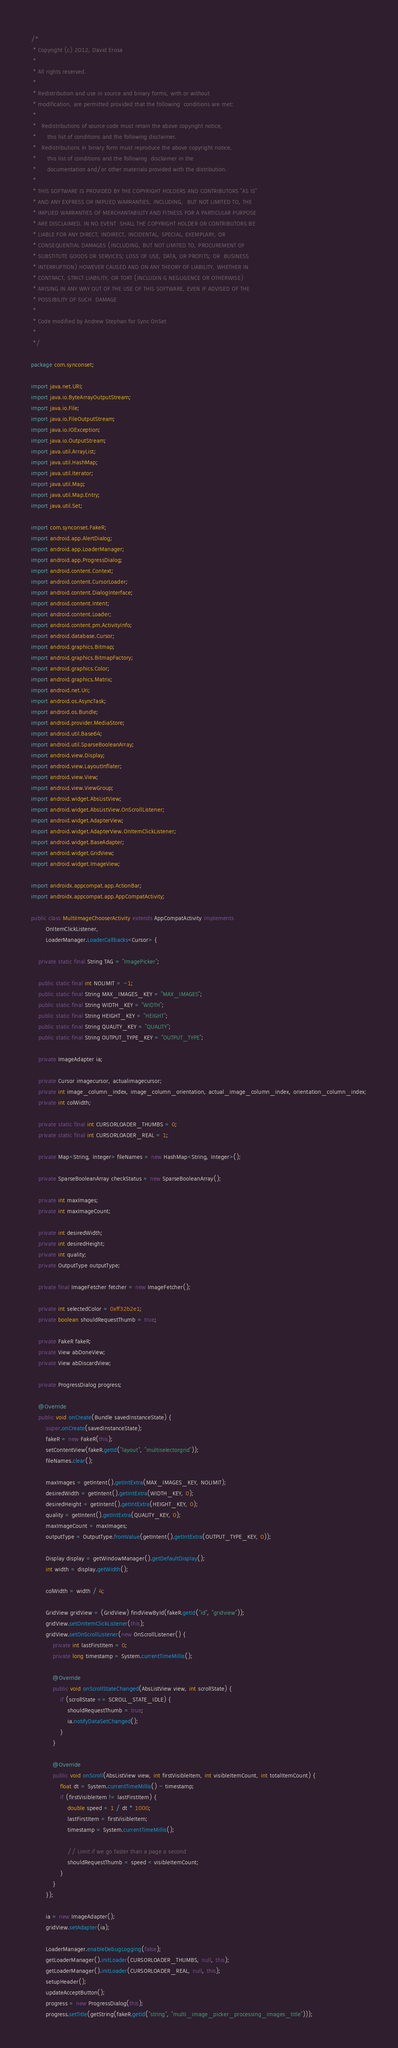Convert code to text. <code><loc_0><loc_0><loc_500><loc_500><_Java_>/*
 * Copyright (c) 2012, David Erosa
 *
 * All rights reserved.
 *
 * Redistribution and use in source and binary forms, with or without
 * modification, are permitted provided that the following  conditions are met:
 *
 *   Redistributions of source code must retain the above copyright notice,
 *      this list of conditions and the following disclaimer.
 *   Redistributions in binary form must reproduce the above copyright notice,
 *      this list of conditions and the following  disclaimer in the
 *      documentation and/or other materials provided with the distribution.
 *
 * THIS SOFTWARE IS PROVIDED BY THE COPYRIGHT HOLDERS AND CONTRIBUTORS "AS IS"
 * AND ANY EXPRESS OR IMPLIED WARRANTIES, INCLUDING,  BUT NOT LIMITED TO, THE
 * IMPLIED WARRANTIES OF MERCHANTABILITY AND FITNESS FOR A PARTICULAR PURPOSE
 * ARE DISCLAIMED. IN NO EVENT  SHALL THE COPYRIGHT HOLDER OR CONTRIBUTORS BE
 * LIABLE FOR ANY DIRECT, INDIRECT, INCIDENTAL, SPECIAL, EXEMPLARY, OR
 * CONSEQUENTIAL DAMAGES (INCLUDING, BUT NOT LIMITED TO, PROCUREMENT OF
 * SUBSTITUTE GOODS OR SERVICES; LOSS OF USE, DATA, OR PROFITS; OR  BUSINESS
 * INTERRUPTION) HOWEVER CAUSED AND ON ANY THEORY OF LIABILITY, WHETHER IN
 * CONTRACT, STRICT LIABILITY, OR TORT (INCLUDIN G NEGLIGENCE OR OTHERWISE)
 * ARISING IN ANY WAY OUT OF THE USE OF THIS SOFTWARE, EVEN IF ADVISED OF THE
 * POSSIBILITY OF SUCH  DAMAGE
 *
 * Code modified by Andrew Stephan for Sync OnSet
 *
 */

package com.synconset;

import java.net.URI;
import java.io.ByteArrayOutputStream;
import java.io.File;
import java.io.FileOutputStream;
import java.io.IOException;
import java.io.OutputStream;
import java.util.ArrayList;
import java.util.HashMap;
import java.util.Iterator;
import java.util.Map;
import java.util.Map.Entry;
import java.util.Set;

import com.synconset.FakeR;
import android.app.AlertDialog;
import android.app.LoaderManager;
import android.app.ProgressDialog;
import android.content.Context;
import android.content.CursorLoader;
import android.content.DialogInterface;
import android.content.Intent;
import android.content.Loader;
import android.content.pm.ActivityInfo;
import android.database.Cursor;
import android.graphics.Bitmap;
import android.graphics.BitmapFactory;
import android.graphics.Color;
import android.graphics.Matrix;
import android.net.Uri;
import android.os.AsyncTask;
import android.os.Bundle;
import android.provider.MediaStore;
import android.util.Base64;
import android.util.SparseBooleanArray;
import android.view.Display;
import android.view.LayoutInflater;
import android.view.View;
import android.view.ViewGroup;
import android.widget.AbsListView;
import android.widget.AbsListView.OnScrollListener;
import android.widget.AdapterView;
import android.widget.AdapterView.OnItemClickListener;
import android.widget.BaseAdapter;
import android.widget.GridView;
import android.widget.ImageView;

import androidx.appcompat.app.ActionBar;
import androidx.appcompat.app.AppCompatActivity;

public class MultiImageChooserActivity extends AppCompatActivity implements
        OnItemClickListener,
        LoaderManager.LoaderCallbacks<Cursor> {

    private static final String TAG = "ImagePicker";

    public static final int NOLIMIT = -1;
    public static final String MAX_IMAGES_KEY = "MAX_IMAGES";
    public static final String WIDTH_KEY = "WIDTH";
    public static final String HEIGHT_KEY = "HEIGHT";
    public static final String QUALITY_KEY = "QUALITY";
    public static final String OUTPUT_TYPE_KEY = "OUTPUT_TYPE";

    private ImageAdapter ia;

    private Cursor imagecursor, actualimagecursor;
    private int image_column_index, image_column_orientation, actual_image_column_index, orientation_column_index;
    private int colWidth;

    private static final int CURSORLOADER_THUMBS = 0;
    private static final int CURSORLOADER_REAL = 1;

    private Map<String, Integer> fileNames = new HashMap<String, Integer>();

    private SparseBooleanArray checkStatus = new SparseBooleanArray();

    private int maxImages;
    private int maxImageCount;

    private int desiredWidth;
    private int desiredHeight;
    private int quality;
    private OutputType outputType;

    private final ImageFetcher fetcher = new ImageFetcher();

    private int selectedColor = 0xff32b2e1;
    private boolean shouldRequestThumb = true;

    private FakeR fakeR;
    private View abDoneView;
    private View abDiscardView;

    private ProgressDialog progress;

    @Override
    public void onCreate(Bundle savedInstanceState) {
        super.onCreate(savedInstanceState);
        fakeR = new FakeR(this);
        setContentView(fakeR.getId("layout", "multiselectorgrid"));
        fileNames.clear();

        maxImages = getIntent().getIntExtra(MAX_IMAGES_KEY, NOLIMIT);
        desiredWidth = getIntent().getIntExtra(WIDTH_KEY, 0);
        desiredHeight = getIntent().getIntExtra(HEIGHT_KEY, 0);
        quality = getIntent().getIntExtra(QUALITY_KEY, 0);
        maxImageCount = maxImages;
        outputType = OutputType.fromValue(getIntent().getIntExtra(OUTPUT_TYPE_KEY, 0));

        Display display = getWindowManager().getDefaultDisplay();
        int width = display.getWidth();

        colWidth = width / 4;

        GridView gridView = (GridView) findViewById(fakeR.getId("id", "gridview"));
        gridView.setOnItemClickListener(this);
        gridView.setOnScrollListener(new OnScrollListener() {
            private int lastFirstItem = 0;
            private long timestamp = System.currentTimeMillis();

            @Override
            public void onScrollStateChanged(AbsListView view, int scrollState) {
                if (scrollState == SCROLL_STATE_IDLE) {
                    shouldRequestThumb = true;
                    ia.notifyDataSetChanged();
                }
            }

            @Override
            public void onScroll(AbsListView view, int firstVisibleItem, int visibleItemCount, int totalItemCount) {
                float dt = System.currentTimeMillis() - timestamp;
                if (firstVisibleItem != lastFirstItem) {
                    double speed = 1 / dt * 1000;
                    lastFirstItem = firstVisibleItem;
                    timestamp = System.currentTimeMillis();

                    // Limit if we go faster than a page a second
                    shouldRequestThumb = speed < visibleItemCount;
                }
            }
        });

        ia = new ImageAdapter();
        gridView.setAdapter(ia);

        LoaderManager.enableDebugLogging(false);
        getLoaderManager().initLoader(CURSORLOADER_THUMBS, null, this);
        getLoaderManager().initLoader(CURSORLOADER_REAL, null, this);
        setupHeader();
        updateAcceptButton();
        progress = new ProgressDialog(this);
        progress.setTitle(getString(fakeR.getId("string", "multi_image_picker_processing_images_title")));</code> 